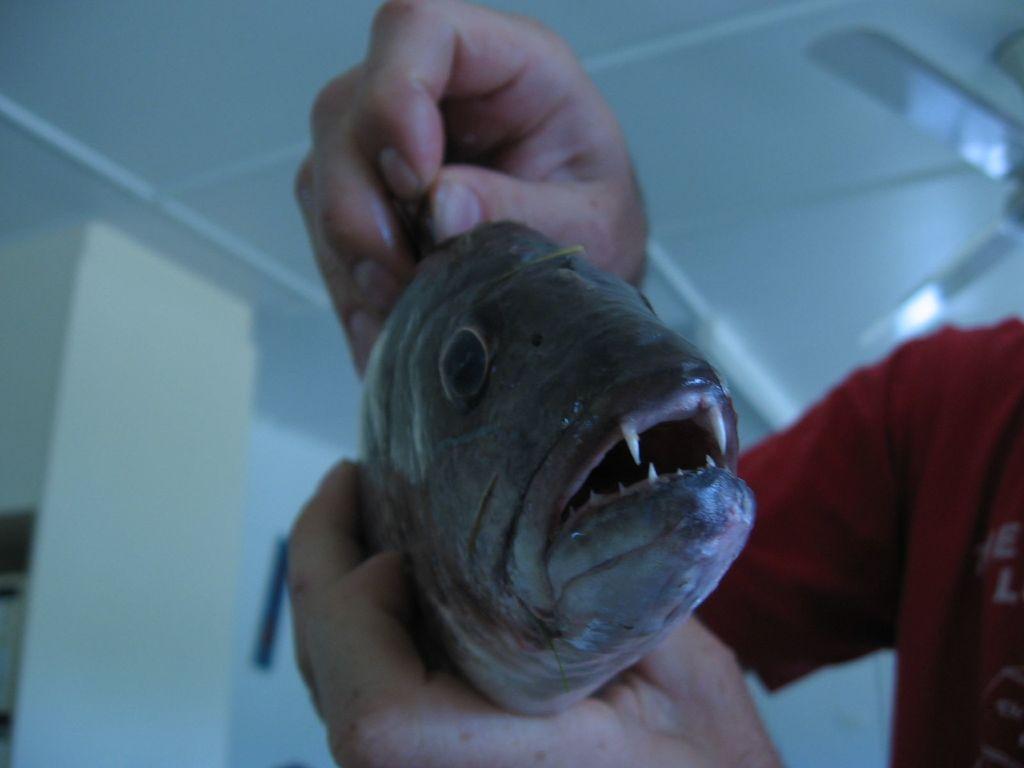How would you summarize this image in a sentence or two? In this image there is a person holding a fish in the hands. Behind the person there is the wall. At the top there is a fan to the ceiling. 